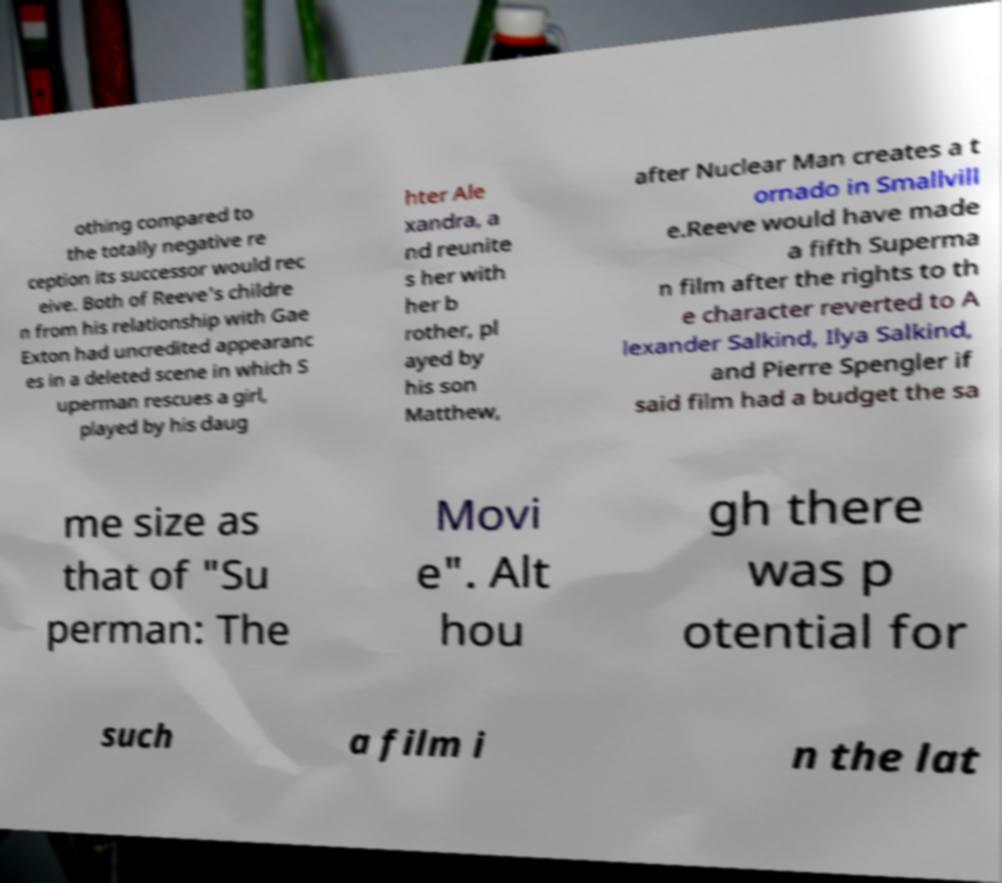What messages or text are displayed in this image? I need them in a readable, typed format. othing compared to the totally negative re ception its successor would rec eive. Both of Reeve's childre n from his relationship with Gae Exton had uncredited appearanc es in a deleted scene in which S uperman rescues a girl, played by his daug hter Ale xandra, a nd reunite s her with her b rother, pl ayed by his son Matthew, after Nuclear Man creates a t ornado in Smallvill e.Reeve would have made a fifth Superma n film after the rights to th e character reverted to A lexander Salkind, Ilya Salkind, and Pierre Spengler if said film had a budget the sa me size as that of "Su perman: The Movi e". Alt hou gh there was p otential for such a film i n the lat 